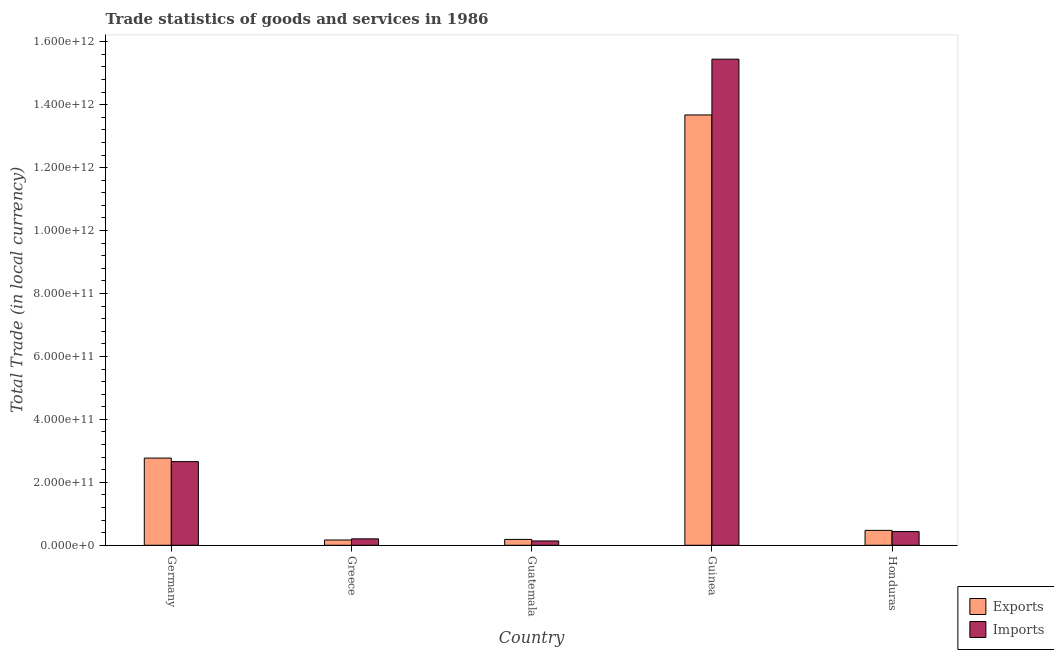How many different coloured bars are there?
Provide a short and direct response. 2. Are the number of bars on each tick of the X-axis equal?
Provide a short and direct response. Yes. What is the label of the 5th group of bars from the left?
Provide a succinct answer. Honduras. What is the export of goods and services in Germany?
Keep it short and to the point. 2.77e+11. Across all countries, what is the maximum export of goods and services?
Your answer should be compact. 1.37e+12. Across all countries, what is the minimum export of goods and services?
Offer a very short reply. 1.68e+1. In which country was the imports of goods and services maximum?
Your answer should be compact. Guinea. In which country was the imports of goods and services minimum?
Your response must be concise. Guatemala. What is the total imports of goods and services in the graph?
Give a very brief answer. 1.89e+12. What is the difference between the export of goods and services in Germany and that in Greece?
Provide a succinct answer. 2.60e+11. What is the difference between the imports of goods and services in Honduras and the export of goods and services in Guatemala?
Offer a very short reply. 2.49e+1. What is the average export of goods and services per country?
Offer a terse response. 3.45e+11. What is the difference between the export of goods and services and imports of goods and services in Guatemala?
Give a very brief answer. 4.83e+09. In how many countries, is the export of goods and services greater than 1440000000000 LCU?
Keep it short and to the point. 0. What is the ratio of the export of goods and services in Greece to that in Honduras?
Ensure brevity in your answer.  0.35. What is the difference between the highest and the second highest imports of goods and services?
Your answer should be very brief. 1.28e+12. What is the difference between the highest and the lowest export of goods and services?
Your answer should be very brief. 1.35e+12. In how many countries, is the imports of goods and services greater than the average imports of goods and services taken over all countries?
Ensure brevity in your answer.  1. Is the sum of the imports of goods and services in Germany and Greece greater than the maximum export of goods and services across all countries?
Provide a short and direct response. No. What does the 1st bar from the left in Honduras represents?
Your answer should be compact. Exports. What does the 1st bar from the right in Germany represents?
Your answer should be very brief. Imports. How many countries are there in the graph?
Give a very brief answer. 5. What is the difference between two consecutive major ticks on the Y-axis?
Make the answer very short. 2.00e+11. Are the values on the major ticks of Y-axis written in scientific E-notation?
Make the answer very short. Yes. How many legend labels are there?
Your response must be concise. 2. How are the legend labels stacked?
Offer a terse response. Vertical. What is the title of the graph?
Offer a very short reply. Trade statistics of goods and services in 1986. What is the label or title of the X-axis?
Your answer should be compact. Country. What is the label or title of the Y-axis?
Give a very brief answer. Total Trade (in local currency). What is the Total Trade (in local currency) in Exports in Germany?
Offer a very short reply. 2.77e+11. What is the Total Trade (in local currency) of Imports in Germany?
Keep it short and to the point. 2.66e+11. What is the Total Trade (in local currency) in Exports in Greece?
Your answer should be very brief. 1.68e+1. What is the Total Trade (in local currency) of Imports in Greece?
Your response must be concise. 2.04e+1. What is the Total Trade (in local currency) in Exports in Guatemala?
Your answer should be compact. 1.86e+1. What is the Total Trade (in local currency) in Imports in Guatemala?
Your answer should be very brief. 1.38e+1. What is the Total Trade (in local currency) in Exports in Guinea?
Ensure brevity in your answer.  1.37e+12. What is the Total Trade (in local currency) in Imports in Guinea?
Keep it short and to the point. 1.54e+12. What is the Total Trade (in local currency) of Exports in Honduras?
Keep it short and to the point. 4.74e+1. What is the Total Trade (in local currency) of Imports in Honduras?
Provide a short and direct response. 4.35e+1. Across all countries, what is the maximum Total Trade (in local currency) in Exports?
Your answer should be very brief. 1.37e+12. Across all countries, what is the maximum Total Trade (in local currency) in Imports?
Give a very brief answer. 1.54e+12. Across all countries, what is the minimum Total Trade (in local currency) in Exports?
Your answer should be compact. 1.68e+1. Across all countries, what is the minimum Total Trade (in local currency) in Imports?
Offer a very short reply. 1.38e+1. What is the total Total Trade (in local currency) of Exports in the graph?
Your answer should be compact. 1.73e+12. What is the total Total Trade (in local currency) in Imports in the graph?
Your answer should be compact. 1.89e+12. What is the difference between the Total Trade (in local currency) of Exports in Germany and that in Greece?
Keep it short and to the point. 2.60e+11. What is the difference between the Total Trade (in local currency) in Imports in Germany and that in Greece?
Your answer should be compact. 2.45e+11. What is the difference between the Total Trade (in local currency) in Exports in Germany and that in Guatemala?
Offer a terse response. 2.58e+11. What is the difference between the Total Trade (in local currency) of Imports in Germany and that in Guatemala?
Ensure brevity in your answer.  2.52e+11. What is the difference between the Total Trade (in local currency) in Exports in Germany and that in Guinea?
Offer a terse response. -1.09e+12. What is the difference between the Total Trade (in local currency) in Imports in Germany and that in Guinea?
Your answer should be compact. -1.28e+12. What is the difference between the Total Trade (in local currency) in Exports in Germany and that in Honduras?
Your response must be concise. 2.30e+11. What is the difference between the Total Trade (in local currency) of Imports in Germany and that in Honduras?
Offer a very short reply. 2.22e+11. What is the difference between the Total Trade (in local currency) of Exports in Greece and that in Guatemala?
Keep it short and to the point. -1.82e+09. What is the difference between the Total Trade (in local currency) in Imports in Greece and that in Guatemala?
Provide a succinct answer. 6.62e+09. What is the difference between the Total Trade (in local currency) in Exports in Greece and that in Guinea?
Your response must be concise. -1.35e+12. What is the difference between the Total Trade (in local currency) in Imports in Greece and that in Guinea?
Keep it short and to the point. -1.52e+12. What is the difference between the Total Trade (in local currency) of Exports in Greece and that in Honduras?
Give a very brief answer. -3.06e+1. What is the difference between the Total Trade (in local currency) of Imports in Greece and that in Honduras?
Provide a succinct answer. -2.31e+1. What is the difference between the Total Trade (in local currency) of Exports in Guatemala and that in Guinea?
Give a very brief answer. -1.35e+12. What is the difference between the Total Trade (in local currency) of Imports in Guatemala and that in Guinea?
Your response must be concise. -1.53e+12. What is the difference between the Total Trade (in local currency) in Exports in Guatemala and that in Honduras?
Provide a short and direct response. -2.88e+1. What is the difference between the Total Trade (in local currency) of Imports in Guatemala and that in Honduras?
Your response must be concise. -2.97e+1. What is the difference between the Total Trade (in local currency) of Exports in Guinea and that in Honduras?
Ensure brevity in your answer.  1.32e+12. What is the difference between the Total Trade (in local currency) in Imports in Guinea and that in Honduras?
Offer a very short reply. 1.50e+12. What is the difference between the Total Trade (in local currency) in Exports in Germany and the Total Trade (in local currency) in Imports in Greece?
Ensure brevity in your answer.  2.57e+11. What is the difference between the Total Trade (in local currency) of Exports in Germany and the Total Trade (in local currency) of Imports in Guatemala?
Keep it short and to the point. 2.63e+11. What is the difference between the Total Trade (in local currency) of Exports in Germany and the Total Trade (in local currency) of Imports in Guinea?
Offer a terse response. -1.27e+12. What is the difference between the Total Trade (in local currency) of Exports in Germany and the Total Trade (in local currency) of Imports in Honduras?
Your answer should be compact. 2.34e+11. What is the difference between the Total Trade (in local currency) in Exports in Greece and the Total Trade (in local currency) in Imports in Guatemala?
Provide a succinct answer. 3.01e+09. What is the difference between the Total Trade (in local currency) in Exports in Greece and the Total Trade (in local currency) in Imports in Guinea?
Ensure brevity in your answer.  -1.53e+12. What is the difference between the Total Trade (in local currency) in Exports in Greece and the Total Trade (in local currency) in Imports in Honduras?
Provide a succinct answer. -2.67e+1. What is the difference between the Total Trade (in local currency) of Exports in Guatemala and the Total Trade (in local currency) of Imports in Guinea?
Your answer should be very brief. -1.53e+12. What is the difference between the Total Trade (in local currency) in Exports in Guatemala and the Total Trade (in local currency) in Imports in Honduras?
Ensure brevity in your answer.  -2.49e+1. What is the difference between the Total Trade (in local currency) of Exports in Guinea and the Total Trade (in local currency) of Imports in Honduras?
Keep it short and to the point. 1.32e+12. What is the average Total Trade (in local currency) of Exports per country?
Give a very brief answer. 3.45e+11. What is the average Total Trade (in local currency) of Imports per country?
Keep it short and to the point. 3.78e+11. What is the difference between the Total Trade (in local currency) of Exports and Total Trade (in local currency) of Imports in Germany?
Offer a terse response. 1.12e+1. What is the difference between the Total Trade (in local currency) in Exports and Total Trade (in local currency) in Imports in Greece?
Give a very brief answer. -3.61e+09. What is the difference between the Total Trade (in local currency) in Exports and Total Trade (in local currency) in Imports in Guatemala?
Provide a short and direct response. 4.83e+09. What is the difference between the Total Trade (in local currency) in Exports and Total Trade (in local currency) in Imports in Guinea?
Make the answer very short. -1.77e+11. What is the difference between the Total Trade (in local currency) of Exports and Total Trade (in local currency) of Imports in Honduras?
Offer a terse response. 3.87e+09. What is the ratio of the Total Trade (in local currency) in Exports in Germany to that in Greece?
Your response must be concise. 16.51. What is the ratio of the Total Trade (in local currency) of Imports in Germany to that in Greece?
Make the answer very short. 13.04. What is the ratio of the Total Trade (in local currency) in Exports in Germany to that in Guatemala?
Your answer should be compact. 14.89. What is the ratio of the Total Trade (in local currency) in Imports in Germany to that in Guatemala?
Offer a very short reply. 19.3. What is the ratio of the Total Trade (in local currency) in Exports in Germany to that in Guinea?
Provide a succinct answer. 0.2. What is the ratio of the Total Trade (in local currency) of Imports in Germany to that in Guinea?
Your response must be concise. 0.17. What is the ratio of the Total Trade (in local currency) in Exports in Germany to that in Honduras?
Provide a succinct answer. 5.85. What is the ratio of the Total Trade (in local currency) of Imports in Germany to that in Honduras?
Offer a terse response. 6.11. What is the ratio of the Total Trade (in local currency) in Exports in Greece to that in Guatemala?
Give a very brief answer. 0.9. What is the ratio of the Total Trade (in local currency) in Imports in Greece to that in Guatemala?
Give a very brief answer. 1.48. What is the ratio of the Total Trade (in local currency) of Exports in Greece to that in Guinea?
Your answer should be very brief. 0.01. What is the ratio of the Total Trade (in local currency) of Imports in Greece to that in Guinea?
Offer a terse response. 0.01. What is the ratio of the Total Trade (in local currency) of Exports in Greece to that in Honduras?
Your answer should be compact. 0.35. What is the ratio of the Total Trade (in local currency) of Imports in Greece to that in Honduras?
Make the answer very short. 0.47. What is the ratio of the Total Trade (in local currency) in Exports in Guatemala to that in Guinea?
Your answer should be very brief. 0.01. What is the ratio of the Total Trade (in local currency) of Imports in Guatemala to that in Guinea?
Provide a short and direct response. 0.01. What is the ratio of the Total Trade (in local currency) in Exports in Guatemala to that in Honduras?
Your response must be concise. 0.39. What is the ratio of the Total Trade (in local currency) of Imports in Guatemala to that in Honduras?
Give a very brief answer. 0.32. What is the ratio of the Total Trade (in local currency) of Exports in Guinea to that in Honduras?
Your answer should be very brief. 28.86. What is the ratio of the Total Trade (in local currency) of Imports in Guinea to that in Honduras?
Give a very brief answer. 35.5. What is the difference between the highest and the second highest Total Trade (in local currency) of Exports?
Keep it short and to the point. 1.09e+12. What is the difference between the highest and the second highest Total Trade (in local currency) of Imports?
Your response must be concise. 1.28e+12. What is the difference between the highest and the lowest Total Trade (in local currency) of Exports?
Provide a short and direct response. 1.35e+12. What is the difference between the highest and the lowest Total Trade (in local currency) in Imports?
Ensure brevity in your answer.  1.53e+12. 